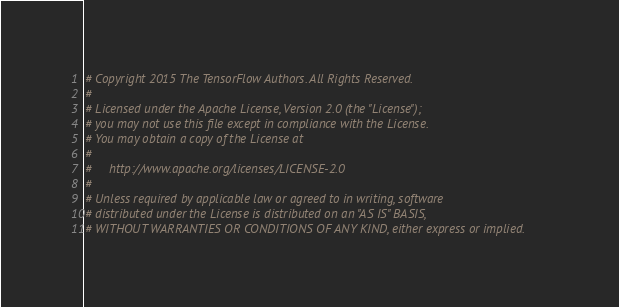Convert code to text. <code><loc_0><loc_0><loc_500><loc_500><_Python_># Copyright 2015 The TensorFlow Authors. All Rights Reserved.
#
# Licensed under the Apache License, Version 2.0 (the "License");
# you may not use this file except in compliance with the License.
# You may obtain a copy of the License at
#
#     http://www.apache.org/licenses/LICENSE-2.0
#
# Unless required by applicable law or agreed to in writing, software
# distributed under the License is distributed on an "AS IS" BASIS,
# WITHOUT WARRANTIES OR CONDITIONS OF ANY KIND, either express or implied.</code> 